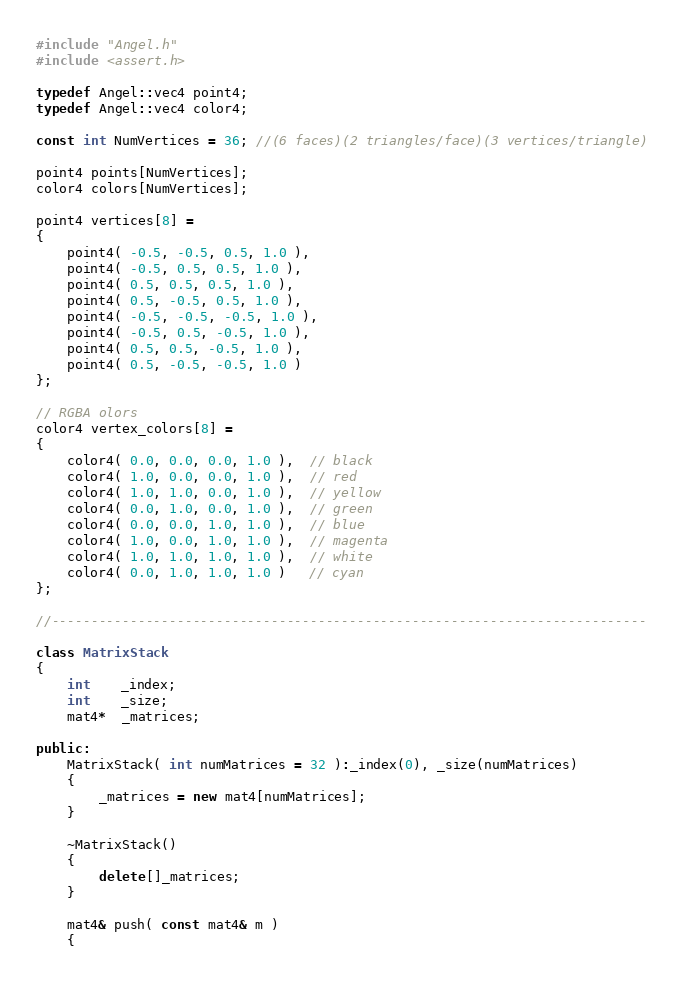<code> <loc_0><loc_0><loc_500><loc_500><_C++_>#include "Angel.h"
#include <assert.h>

typedef Angel::vec4 point4;
typedef Angel::vec4 color4;

const int NumVertices = 36; //(6 faces)(2 triangles/face)(3 vertices/triangle)

point4 points[NumVertices];
color4 colors[NumVertices];

point4 vertices[8] =
{
    point4( -0.5, -0.5, 0.5, 1.0 ),
    point4( -0.5, 0.5, 0.5, 1.0 ),
    point4( 0.5, 0.5, 0.5, 1.0 ),
    point4( 0.5, -0.5, 0.5, 1.0 ),
    point4( -0.5, -0.5, -0.5, 1.0 ),
    point4( -0.5, 0.5, -0.5, 1.0 ),
    point4( 0.5, 0.5, -0.5, 1.0 ),
    point4( 0.5, -0.5, -0.5, 1.0 )
};

// RGBA olors
color4 vertex_colors[8] =
{
    color4( 0.0, 0.0, 0.0, 1.0 ),  // black
    color4( 1.0, 0.0, 0.0, 1.0 ),  // red
    color4( 1.0, 1.0, 0.0, 1.0 ),  // yellow
    color4( 0.0, 1.0, 0.0, 1.0 ),  // green
    color4( 0.0, 0.0, 1.0, 1.0 ),  // blue
    color4( 1.0, 0.0, 1.0, 1.0 ),  // magenta
    color4( 1.0, 1.0, 1.0, 1.0 ),  // white
    color4( 0.0, 1.0, 1.0, 1.0 )   // cyan
};

//----------------------------------------------------------------------------

class MatrixStack
{
    int    _index;
    int    _size;
    mat4*  _matrices;

public:
    MatrixStack( int numMatrices = 32 ):_index(0), _size(numMatrices)
    {
        _matrices = new mat4[numMatrices];
    }

    ~MatrixStack()
    {
        delete[]_matrices;
    }

    mat4& push( const mat4& m )
    {</code> 